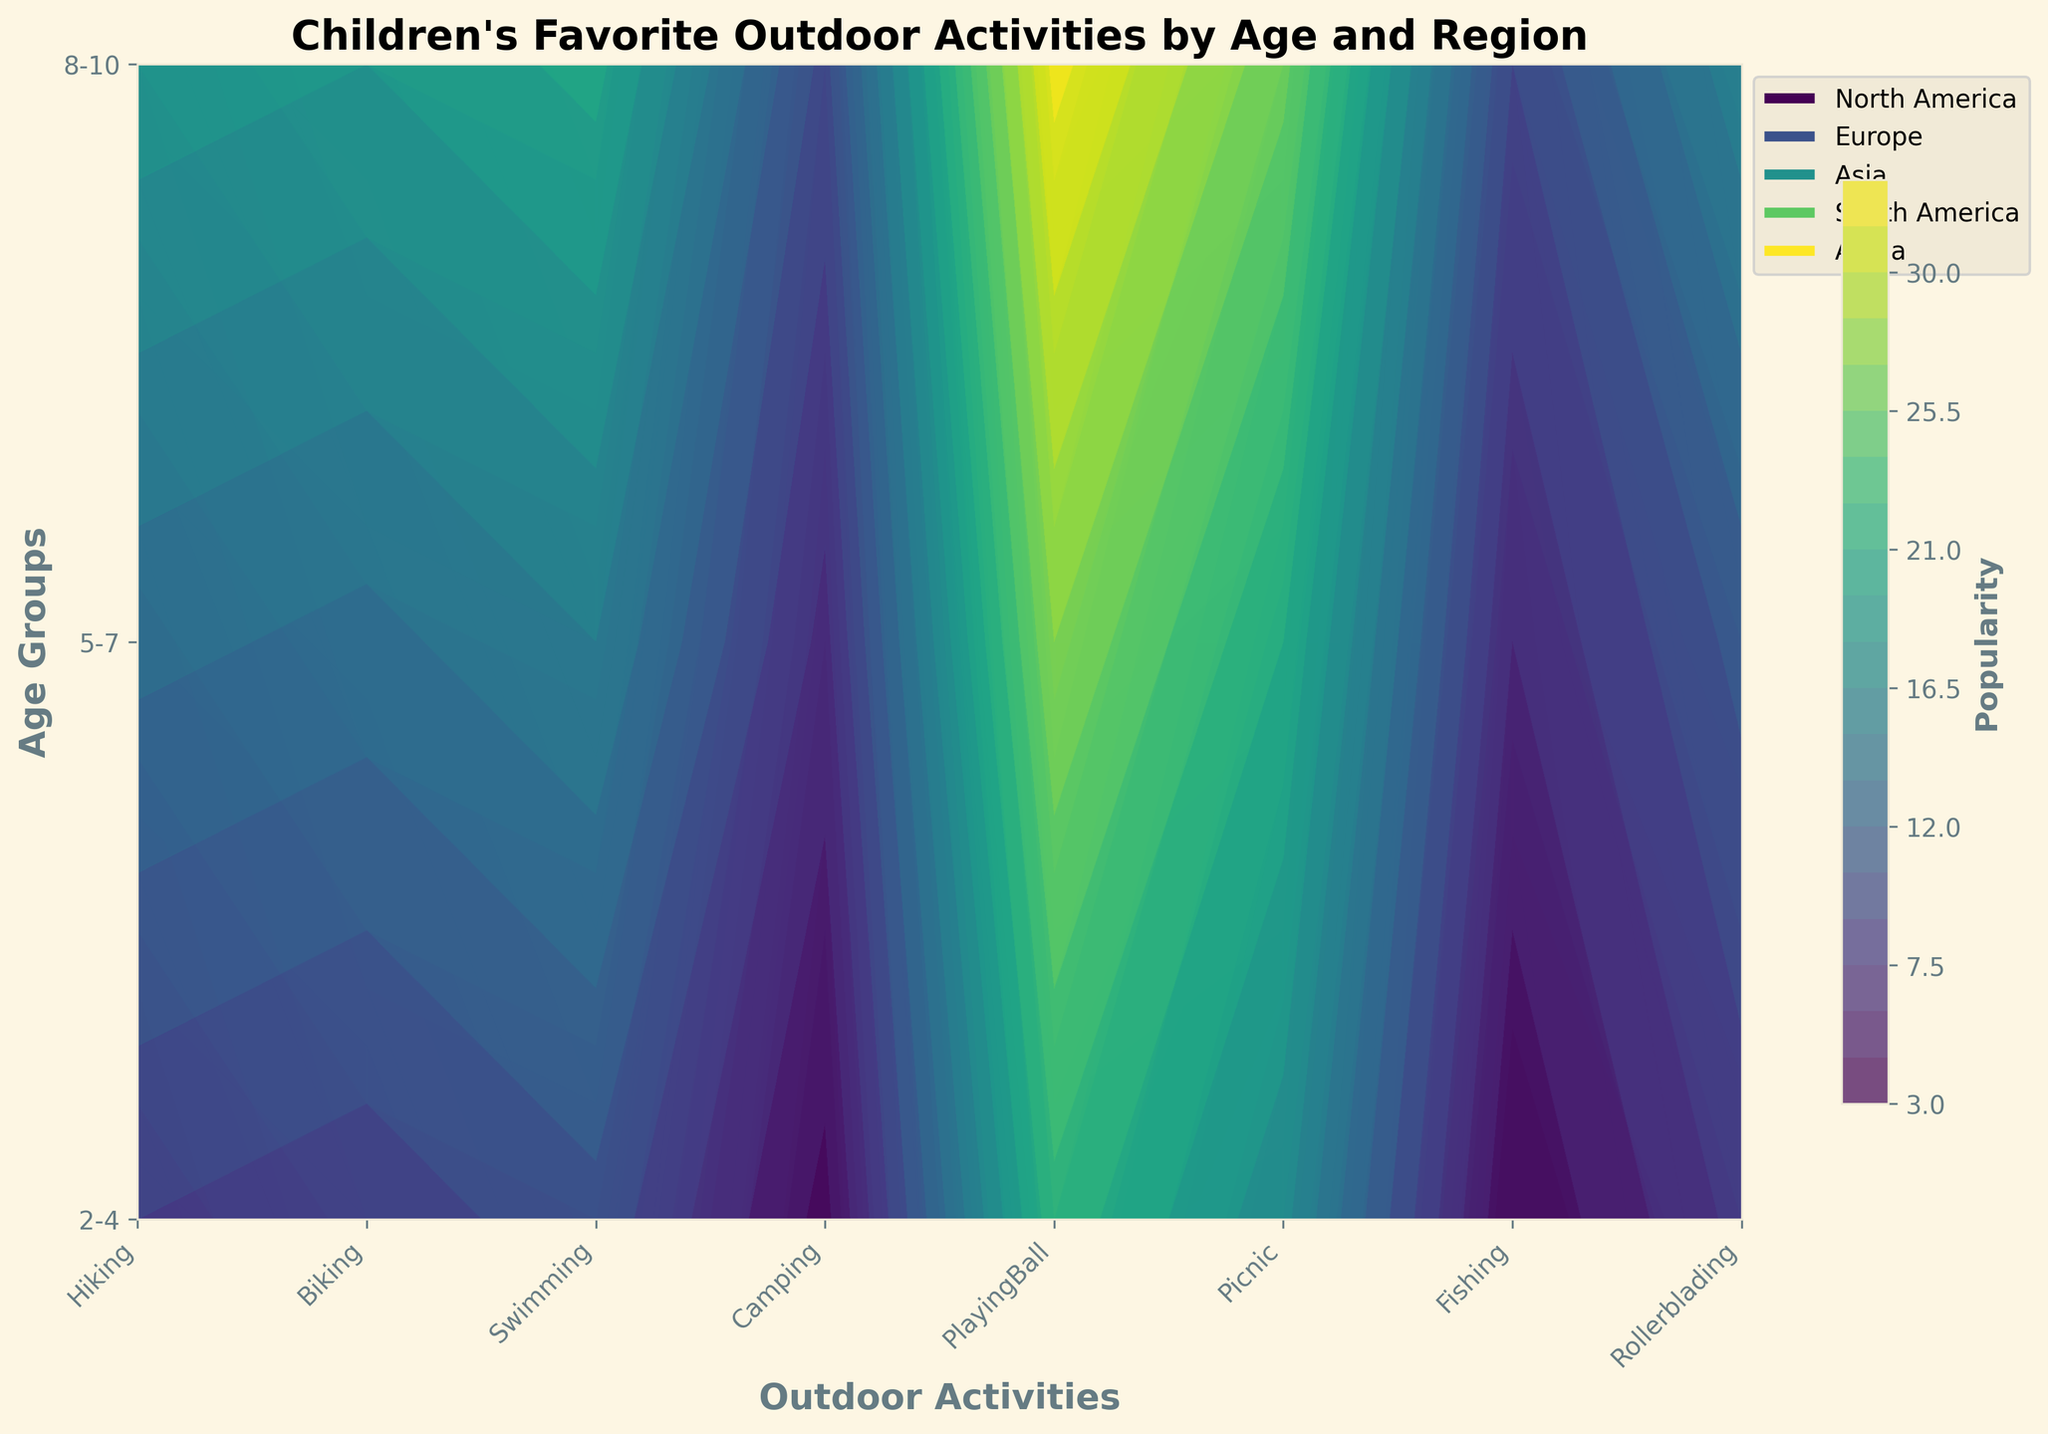What's the most popular activity for children aged 2-4 in North America? In the contour plot, find the contour block corresponding to age group "2-4" and the region "North America." Check the contour labels to find the highest one, which represents the most popular activity.
Answer: PlayingBall Which region shows the highest popularity for swimming among children aged 8-10? Locate the row for age group "8-10" and compare the levels of the contour labels corresponding to the swimming column across different regions. Determine which region has the highest value.
Answer: North America Across all age groups, which activity is consistently less popular in Africa compared to other regions? Check the levels of the contour labels for each activity in Africa and compare them with other regions for each age group. Identify the activity that consistently shows lower values in Africa.
Answer: Hiking What is the average popularity of camping for the age group 5-7 across all regions? Find the contour labels for camping in the row corresponding to age group "5-7" for all regions. Add up these values (6 + 7 + 5 + 6 + 7 = 31) and divide by the number of regions (5) to get the average.
Answer: 6.2 How does the popularity of rollerblading change from age group 2-4 to 8-10 in Europe? Compare the contour labels for rollerblading in Europe for age group "2-4" with "8-10." Note the increase or decrease in popularity.
Answer: It increases Which age group has the most evenly distributed popularity across all activities in Asia? Examine the contour labels for each age group in Asia and identify the age group with activity values closest to each other, without large fluctuations.
Answer: 2-4 Is there a region where playing ball is the top activity for all age groups? Check the contour labels for the playing ball activity across all age groups for each region and identify if there is a region where playing ball has the highest value consistently.
Answer: No Which activity shows the most growth in popularity as children age from 2-4 to 8-10 in South America? Compare the contour labels for each activity in South America for age group "2-4" and "8-10." Identify the activity with the largest increase in values.
Answer: Hockey 